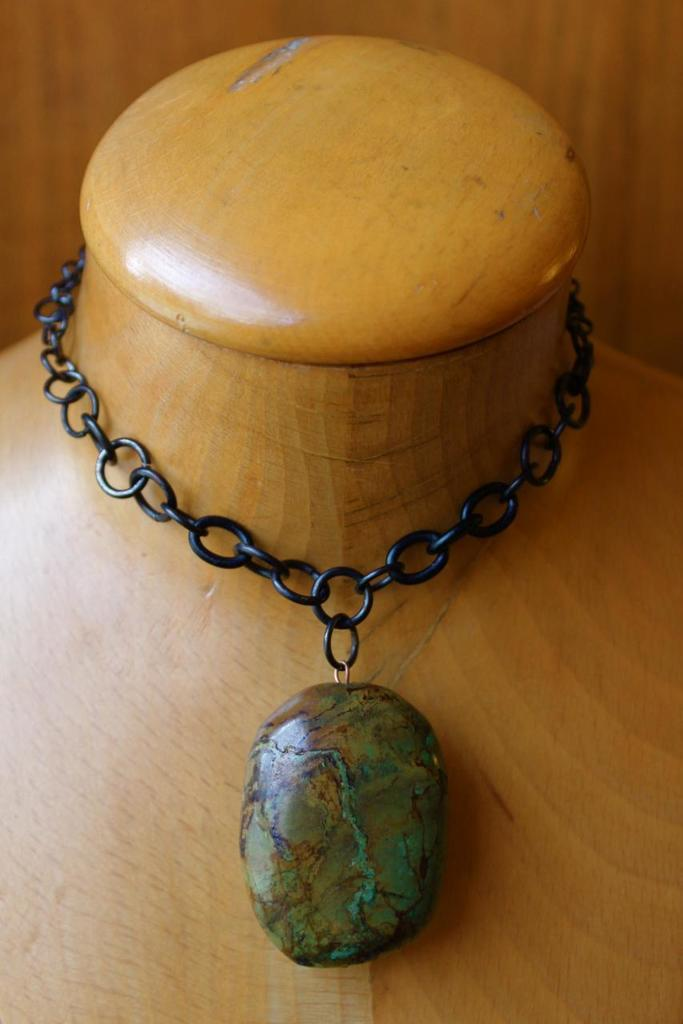What can be seen in the image that is decorative? There is an ornament in the image. What is the ornament placed on? The ornament is on a wooden object. What type of material is visible in the background of the image? There is a wooden wall visible in the image. Can you hear the sound of cherries being picked in space in the image? There is no sound, cherries, or space present in the image; it features an ornament on a wooden object in front of a wooden wall. 